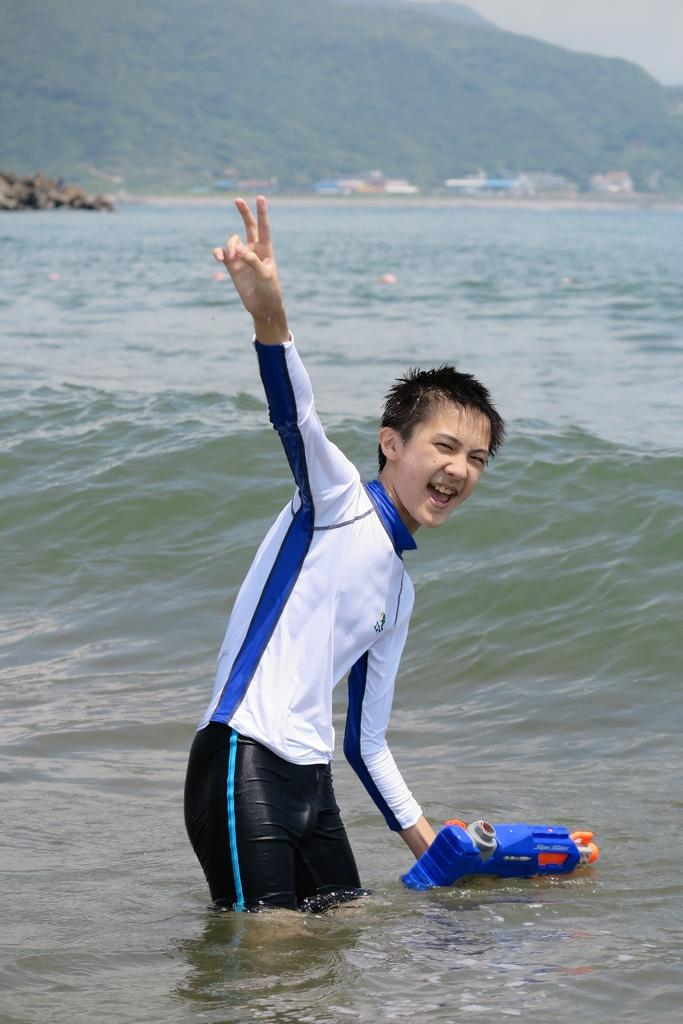What is the boy doing in the image? The boy is in the water. What is the boy wearing in the image? The boy is wearing a T-shirt and pants. What is the boy holding in his hand in the image? The boy is holding an object in his hand. What can be seen at the top of the image? There is greenery and buildings visible at the top of the image. What type of oatmeal is the boy eating in the image? There is no oatmeal present in the image; the boy is in the water and not eating anything. How many leaves are on the tree in the image? There is no tree present in the image, so it is not possible to determine the number of leaves. 